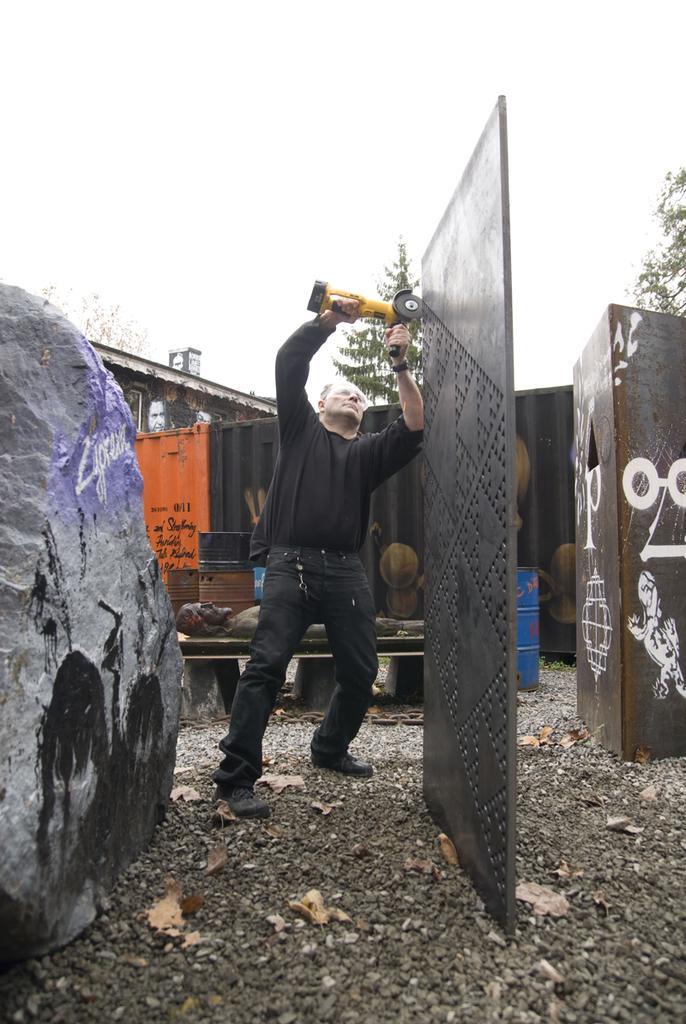Can you describe this image briefly? In this picture there is a person wearing black dress is standing and holding an object in his hands and there is a black color object in front of him and there is a rock in the left corner and there are few containers and some other objects in the background. 